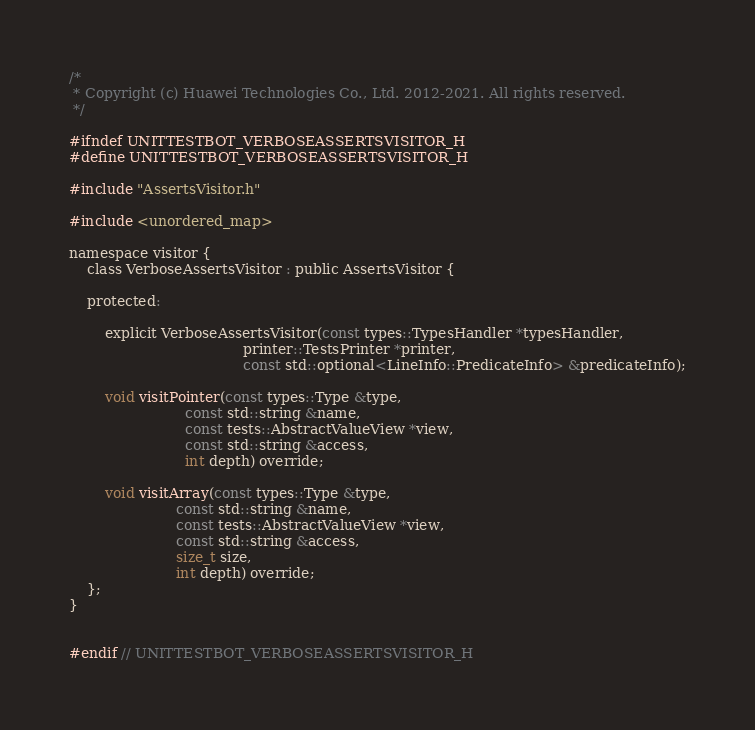Convert code to text. <code><loc_0><loc_0><loc_500><loc_500><_C_>/*
 * Copyright (c) Huawei Technologies Co., Ltd. 2012-2021. All rights reserved.
 */

#ifndef UNITTESTBOT_VERBOSEASSERTSVISITOR_H
#define UNITTESTBOT_VERBOSEASSERTSVISITOR_H

#include "AssertsVisitor.h"

#include <unordered_map>

namespace visitor {
    class VerboseAssertsVisitor : public AssertsVisitor {

    protected:

        explicit VerboseAssertsVisitor(const types::TypesHandler *typesHandler,
                                       printer::TestsPrinter *printer,
                                       const std::optional<LineInfo::PredicateInfo> &predicateInfo);

        void visitPointer(const types::Type &type,
                          const std::string &name,
                          const tests::AbstractValueView *view,
                          const std::string &access,
                          int depth) override;

        void visitArray(const types::Type &type,
                        const std::string &name,
                        const tests::AbstractValueView *view,
                        const std::string &access,
                        size_t size,
                        int depth) override;
    };
}


#endif // UNITTESTBOT_VERBOSEASSERTSVISITOR_H
</code> 